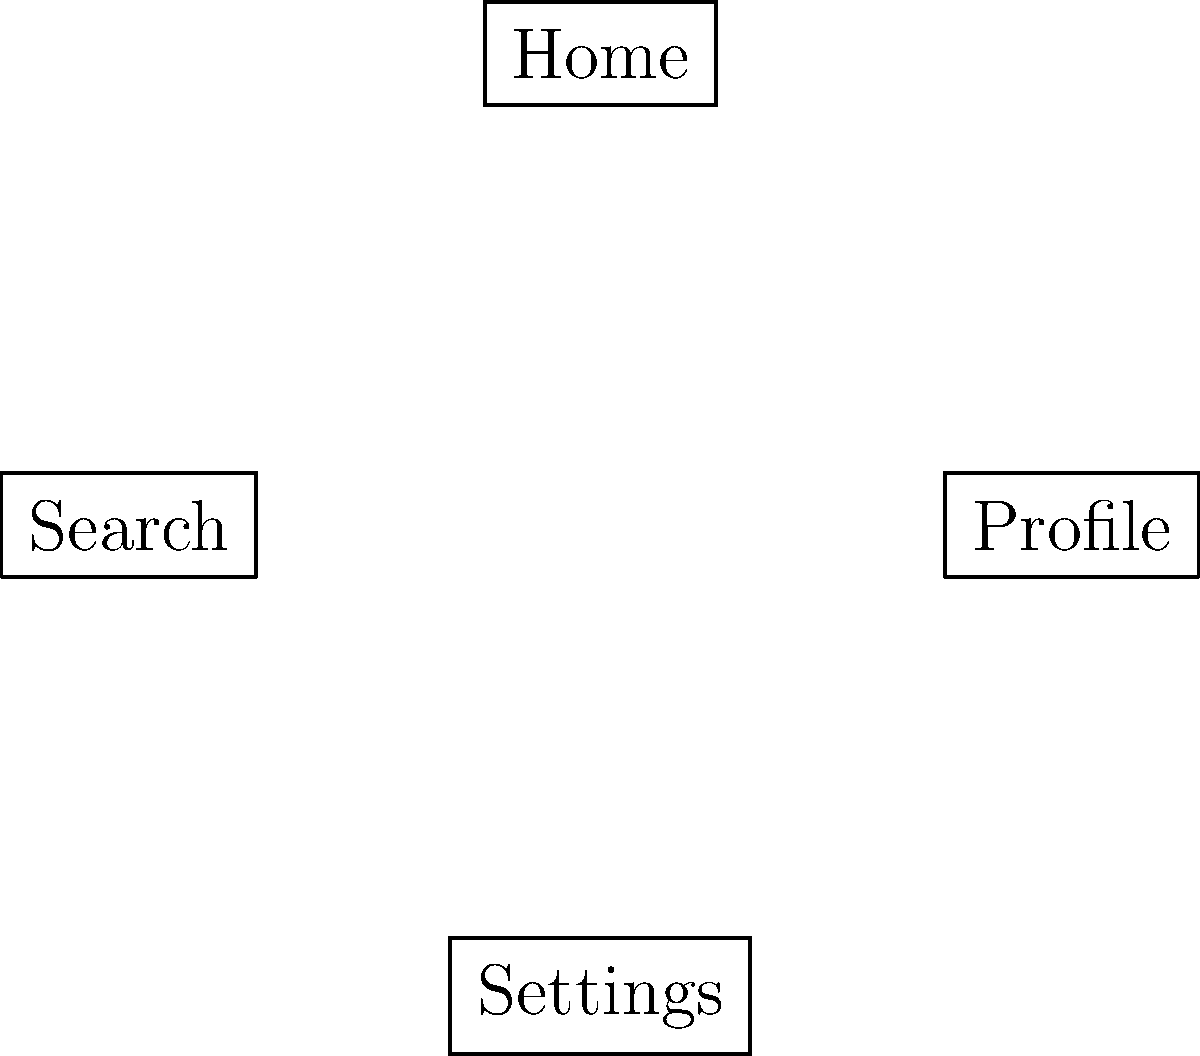Based on the vector flowchart of an app structure, which navigation pattern is most likely to reduce user friction and improve overall user experience? To determine the navigation pattern that reduces user friction and improves overall user experience, we need to analyze the flowchart:

1. The flowchart shows a home-centric design with direct access to Search and Profile from the Home screen.
2. Both Search and Profile have direct access to Settings.
3. Settings has a direct path back to Home, creating a loop.

Step-by-step analysis:
1. Home-centric design: This allows users to easily navigate to main features (Search and Profile) from a central location, reducing the number of taps required.
2. Direct access to Settings: Users can quickly access Settings from both Search and Profile, improving efficiency for task completion.
3. Loop back to Home: The ability to return to Home from Settings provides a clear exit point and prevents users from feeling trapped in a deep navigation structure.

This navigation pattern follows these user-centric design principles:
- Minimal depth: Users can reach most features within 1-2 taps.
- Clear structure: The layout is intuitive and easy to understand.
- Efficient paths: Direct connections between frequently used features.

Therefore, this navigation pattern is likely to reduce user friction by minimizing the number of steps required to access key features and providing clear pathways between different sections of the app.
Answer: Home-centric design with direct access to main features 